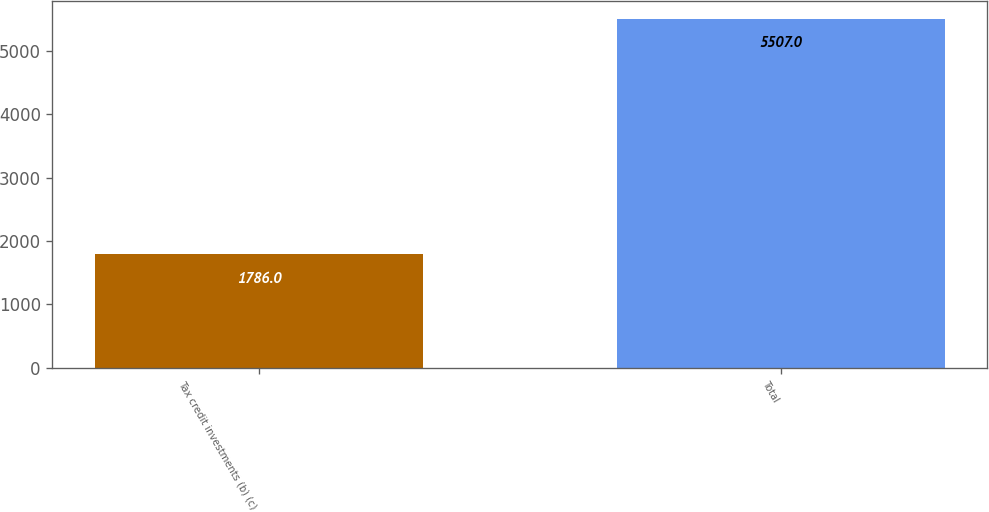Convert chart to OTSL. <chart><loc_0><loc_0><loc_500><loc_500><bar_chart><fcel>Tax credit investments (b) (c)<fcel>Total<nl><fcel>1786<fcel>5507<nl></chart> 